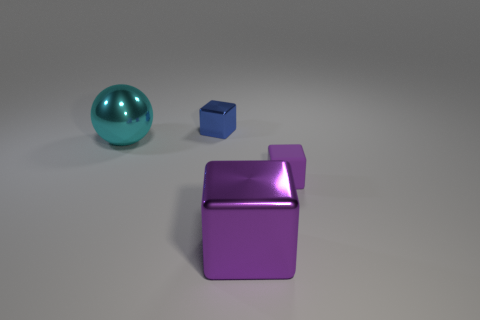Subtract all big purple blocks. How many blocks are left? 2 Add 2 tiny shiny blocks. How many objects exist? 6 Subtract all balls. How many objects are left? 3 Subtract all blue blocks. How many blocks are left? 2 Subtract 0 cyan cubes. How many objects are left? 4 Subtract 1 balls. How many balls are left? 0 Subtract all purple spheres. Subtract all yellow cylinders. How many spheres are left? 1 Subtract all yellow balls. How many purple blocks are left? 2 Subtract all small cyan objects. Subtract all large purple objects. How many objects are left? 3 Add 2 small purple matte cubes. How many small purple matte cubes are left? 3 